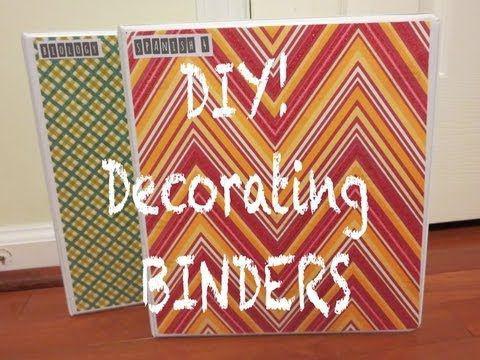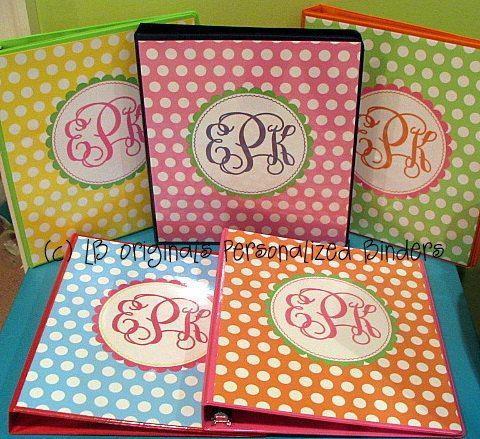The first image is the image on the left, the second image is the image on the right. Assess this claim about the two images: "There are five colorful notebooks in one of the images.". Correct or not? Answer yes or no. Yes. 